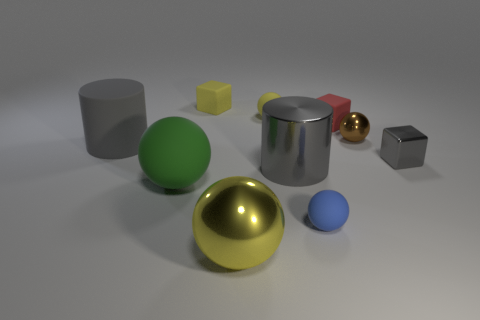What is the size of the gray metallic cylinder?
Provide a succinct answer. Large. What material is the big thing that is the same color as the matte cylinder?
Your response must be concise. Metal. What number of other big matte cylinders have the same color as the rubber cylinder?
Ensure brevity in your answer.  0. Does the shiny cylinder have the same size as the yellow metallic ball?
Keep it short and to the point. Yes. There is a red matte thing that is behind the gray object on the right side of the small red matte block; what size is it?
Ensure brevity in your answer.  Small. Does the tiny metal block have the same color as the big thing behind the gray shiny cylinder?
Your response must be concise. Yes. Is there a blue matte object of the same size as the green sphere?
Offer a very short reply. No. What is the size of the yellow ball that is in front of the blue object?
Offer a very short reply. Large. There is a yellow ball behind the small gray thing; is there a tiny rubber sphere on the right side of it?
Your answer should be very brief. Yes. What number of other things are the same shape as the small red rubber object?
Your answer should be very brief. 2. 